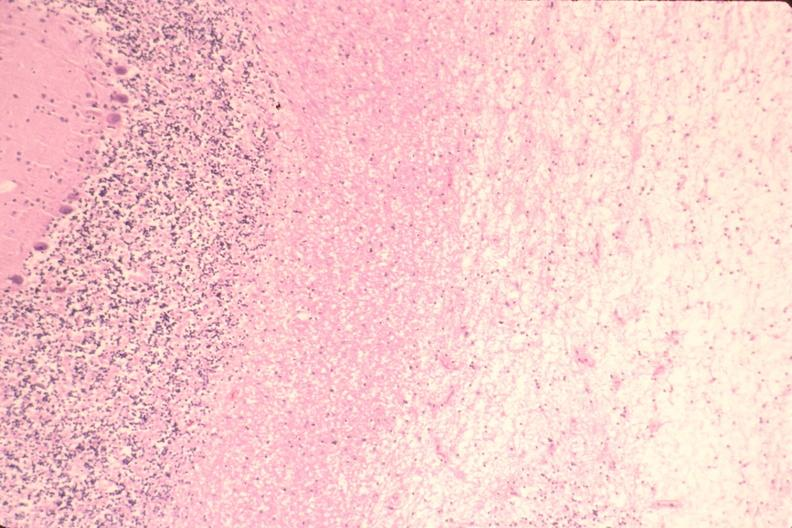what is present?
Answer the question using a single word or phrase. Nervous 